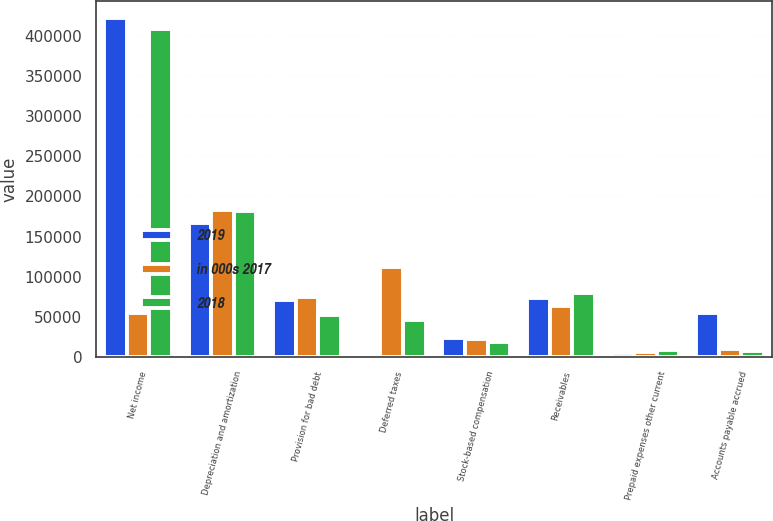Convert chart. <chart><loc_0><loc_0><loc_500><loc_500><stacked_bar_chart><ecel><fcel>Net income<fcel>Depreciation and amortization<fcel>Provision for bad debt<fcel>Deferred taxes<fcel>Stock-based compensation<fcel>Receivables<fcel>Prepaid expenses other current<fcel>Accounts payable accrued<nl><fcel>2019<fcel>422509<fcel>166695<fcel>70569<fcel>1129<fcel>23767<fcel>73648<fcel>4503<fcel>54827<nl><fcel>in 000s 2017<fcel>54827<fcel>183295<fcel>74489<fcel>112140<fcel>21954<fcel>63935<fcel>6453<fcel>10532<nl><fcel>2018<fcel>408945<fcel>182168<fcel>52776<fcel>46455<fcel>19285<fcel>80210<fcel>8569<fcel>7683<nl></chart> 